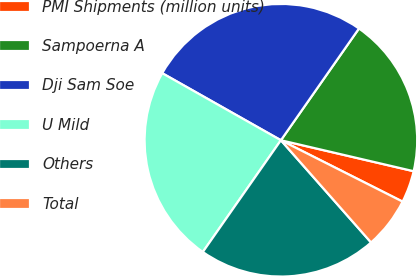<chart> <loc_0><loc_0><loc_500><loc_500><pie_chart><fcel>PMI Shipments (million units)<fcel>Sampoerna A<fcel>Dji Sam Soe<fcel>U Mild<fcel>Others<fcel>Total<nl><fcel>3.79%<fcel>18.94%<fcel>26.52%<fcel>23.48%<fcel>21.21%<fcel>6.06%<nl></chart> 